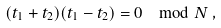<formula> <loc_0><loc_0><loc_500><loc_500>( t _ { 1 } + t _ { 2 } ) ( t _ { 1 } - t _ { 2 } ) = 0 \mod N \, ,</formula> 